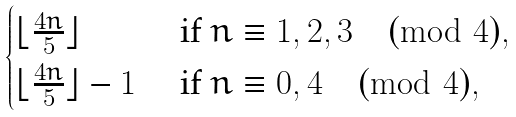Convert formula to latex. <formula><loc_0><loc_0><loc_500><loc_500>\begin{cases} \lfloor \frac { 4 n } { 5 } \rfloor & \text { if } n \equiv 1 , 2 , 3 \pmod { 4 } , \\ \lfloor \frac { 4 n } { 5 } \rfloor - 1 & \text { if } n \equiv 0 , 4 \pmod { 4 } , \end{cases}</formula> 